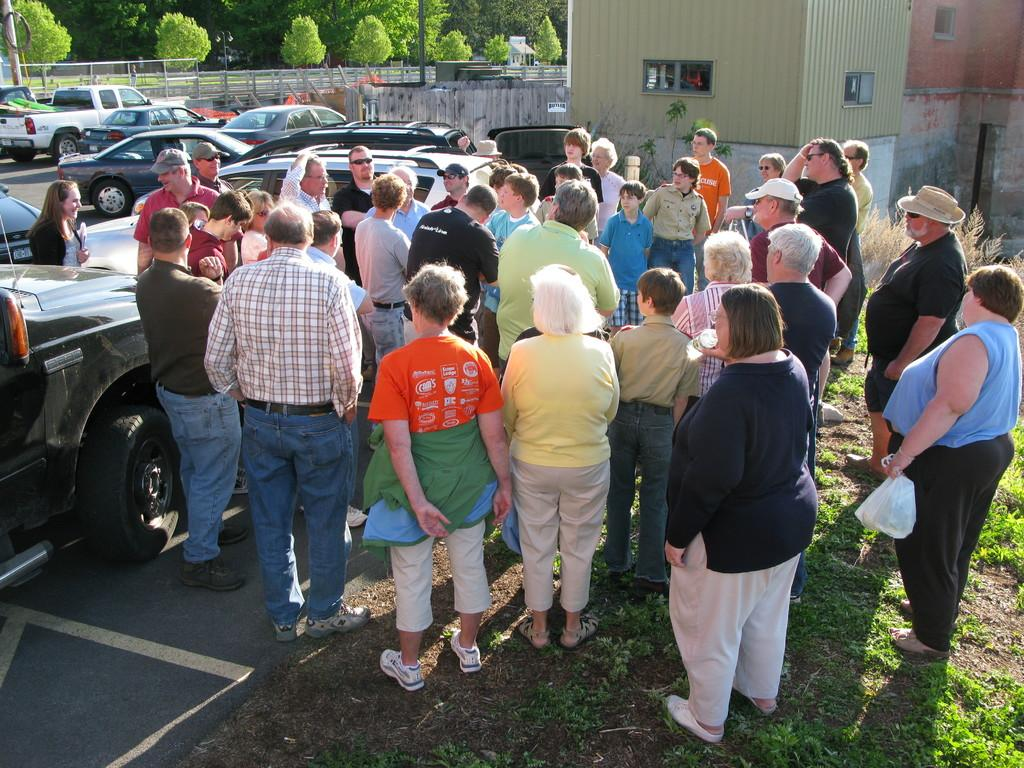What is happening in the center of the image? There are people standing in the center of the image. What can be seen on the left side of the image? There are cars on the left side of the image. What type of vegetation is visible at the top side of the image? There are trees at the top side of the image. How many frogs are sitting under the umbrella in the image? There are no frogs or umbrellas present in the image. What type of doll is placed on the trees in the image? There are no dolls present in the image, and the trees are not associated with any dolls. 